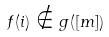<formula> <loc_0><loc_0><loc_500><loc_500>f ( i ) \notin g ( [ m ] )</formula> 